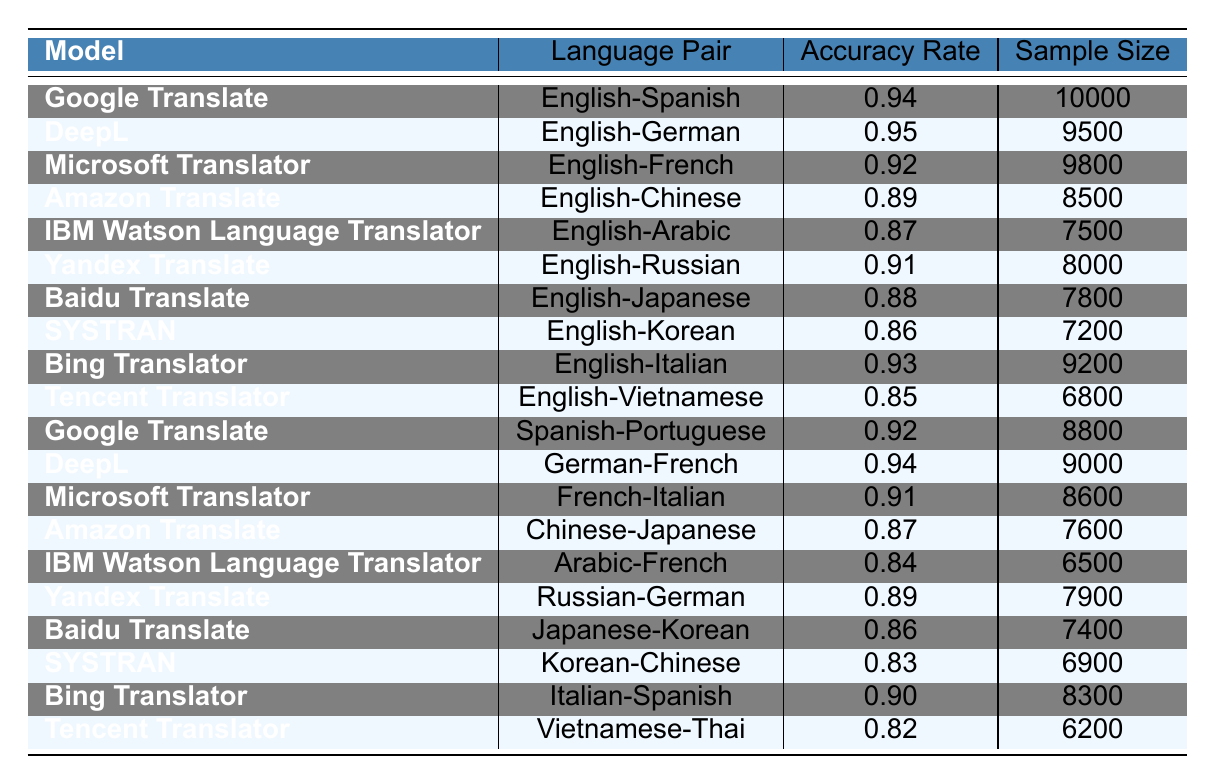What is the accuracy rate of Google Translate for English-Spanish? According to the table, the accuracy rate for Google Translate with the English-Spanish language pair is listed as 0.94.
Answer: 0.94 Which translation model has the highest accuracy rate overall? In the table, DeepL for the English-German pair has the highest accuracy rate at 0.95, making it the leading model overall.
Answer: DeepL What is the sample size for MSN Translator in the English-French pair? The table shows that Microsoft Translator has a sample size of 9800 for the English-French language pair.
Answer: 9800 Is there a translation model with an accuracy rate below 0.85? Yes, SYSTRAN for Korean-Chinese has an accuracy rate of 0.83, which is below 0.85.
Answer: Yes What is the average accuracy rate of all models for language pairs involving English? To calculate the average, we sum the accuracy rates for the English language pairs (0.94 + 0.95 + 0.92 + 0.89 + 0.87 + 0.91 + 0.88 + 0.86 + 0.93 + 0.85) = 8.05, and since there are 10 models, the average is 8.05 / 10 = 0.805.
Answer: 0.805 Which translation model is the least accurate for Japanese-Korean? According to the table, Baidu Translate has an accuracy rate of 0.86 for the Japanese-Korean pair, which is the lowest for that language pair.
Answer: Baidu Translate Compare the accuracy rates of Amazon Translate for English-Chinese and Chinese-Japanese. Amazon Translate shows an accuracy rate of 0.89 for English-Chinese and 0.87 for Chinese-Japanese. Since 0.89 > 0.87, it is more accurate for the English-Chinese pair.
Answer: More accurate for English-Chinese What is the difference in accuracy between Bing Translator for English-Italian and Italian-Spanish? The accuracy rate for Bing Translator for English-Italian is 0.93 and for Italian-Spanish is 0.90. The difference is 0.93 - 0.90 = 0.03.
Answer: 0.03 Among the models listed, which one demonstrates accuracy for both Arabic-French and English-Arabic? IBM Watson Language Translator shows an accuracy rate of 0.84 for Arabic-French and 0.87 for English-Arabic, thus it demonstrates accuracy for both pairs.
Answer: IBM Watson Language Translator What percentage of language pairs in the table show an accuracy rate of 0.90 or higher? There are 8 language pairs with an accuracy of 0.90 or above (Google Translate, DeepL, Microsoft Translator, Bing Translator, etc.) out of 20 total pairs, so (8/20) * 100 = 40%.
Answer: 40% 